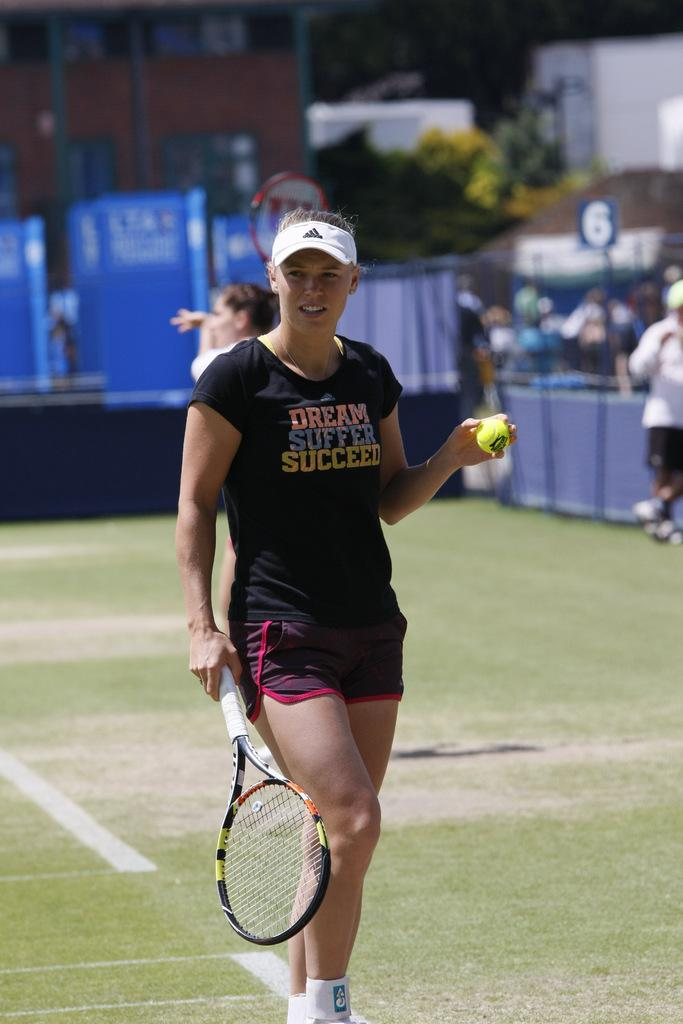Who is present in the image? There is a woman in the image. What is the woman holding in the image? The woman is holding a tennis racket and a tennis ball. What can be seen in the background of the image? There is an audience and plants in the background of the image. Can you see any steam coming from the tennis racket in the image? No, there is no steam present in the image. 